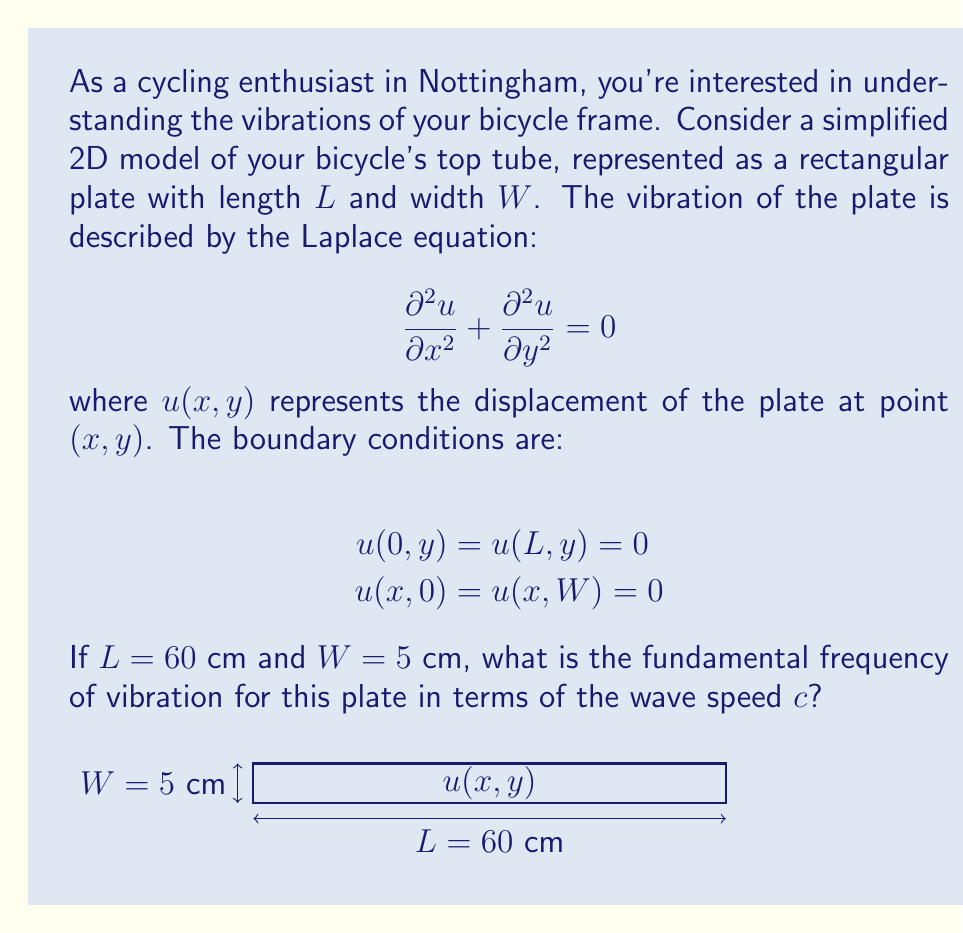Can you answer this question? Let's approach this step-by-step:

1) The general solution to the 2D Laplace equation with these boundary conditions is:

   $$u(x,y) = \sum_{m=1}^{\infty}\sum_{n=1}^{\infty}A_{mn}\sin(\frac{m\pi x}{L})\sin(\frac{n\pi y}{W})$$

2) The corresponding frequency for each mode $(m,n)$ is given by:

   $$f_{mn} = \frac{c}{2}\sqrt{(\frac{m}{L})^2 + (\frac{n}{W})^2}$$

3) The fundamental frequency is the lowest non-zero frequency, which occurs when $m=1$ and $n=1$:

   $$f_{11} = \frac{c}{2}\sqrt{(\frac{1}{L})^2 + (\frac{1}{W})^2}$$

4) Substituting the given values $L = 60$ cm and $W = 5$ cm:

   $$f_{11} = \frac{c}{2}\sqrt{(\frac{1}{60})^2 + (\frac{1}{5})^2}$$

5) Simplify:
   
   $$f_{11} = \frac{c}{2}\sqrt{\frac{1}{3600} + \frac{1}{25}} = \frac{c}{2}\sqrt{\frac{25 + 144}{3600}} = \frac{c}{2}\sqrt{\frac{169}{3600}}$$

6) Further simplification:

   $$f_{11} = \frac{c}{2}\frac{\sqrt{169}}{\sqrt{3600}} = \frac{13c}{120}$$
Answer: $\frac{13c}{120}$ Hz 